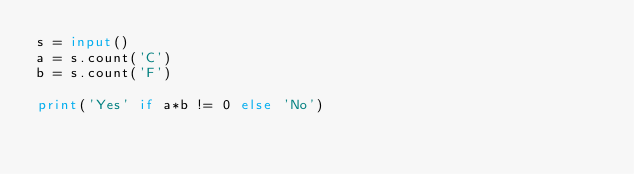<code> <loc_0><loc_0><loc_500><loc_500><_Python_>s = input()
a = s.count('C')
b = s.count('F')

print('Yes' if a*b != 0 else 'No')</code> 